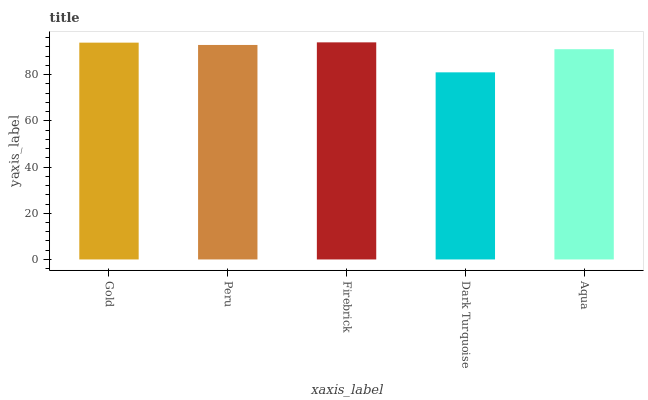Is Dark Turquoise the minimum?
Answer yes or no. Yes. Is Firebrick the maximum?
Answer yes or no. Yes. Is Peru the minimum?
Answer yes or no. No. Is Peru the maximum?
Answer yes or no. No. Is Gold greater than Peru?
Answer yes or no. Yes. Is Peru less than Gold?
Answer yes or no. Yes. Is Peru greater than Gold?
Answer yes or no. No. Is Gold less than Peru?
Answer yes or no. No. Is Peru the high median?
Answer yes or no. Yes. Is Peru the low median?
Answer yes or no. Yes. Is Gold the high median?
Answer yes or no. No. Is Dark Turquoise the low median?
Answer yes or no. No. 